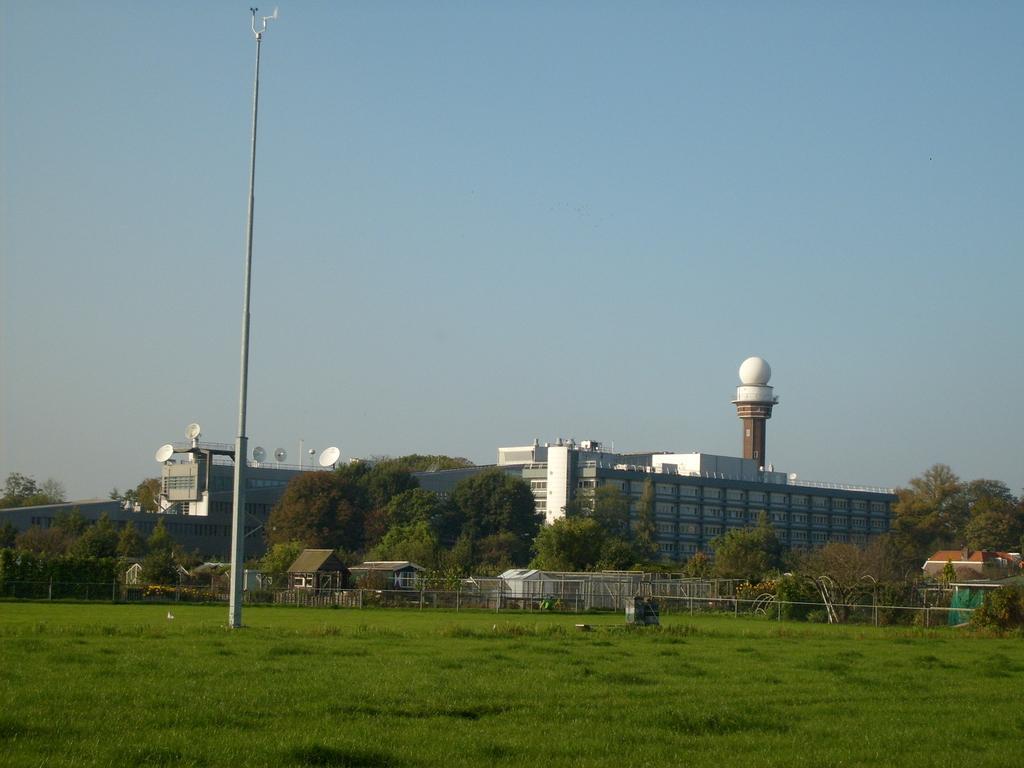How would you summarize this image in a sentence or two? In this image we can see sky, pole, buildings, fence, trees and shed. 